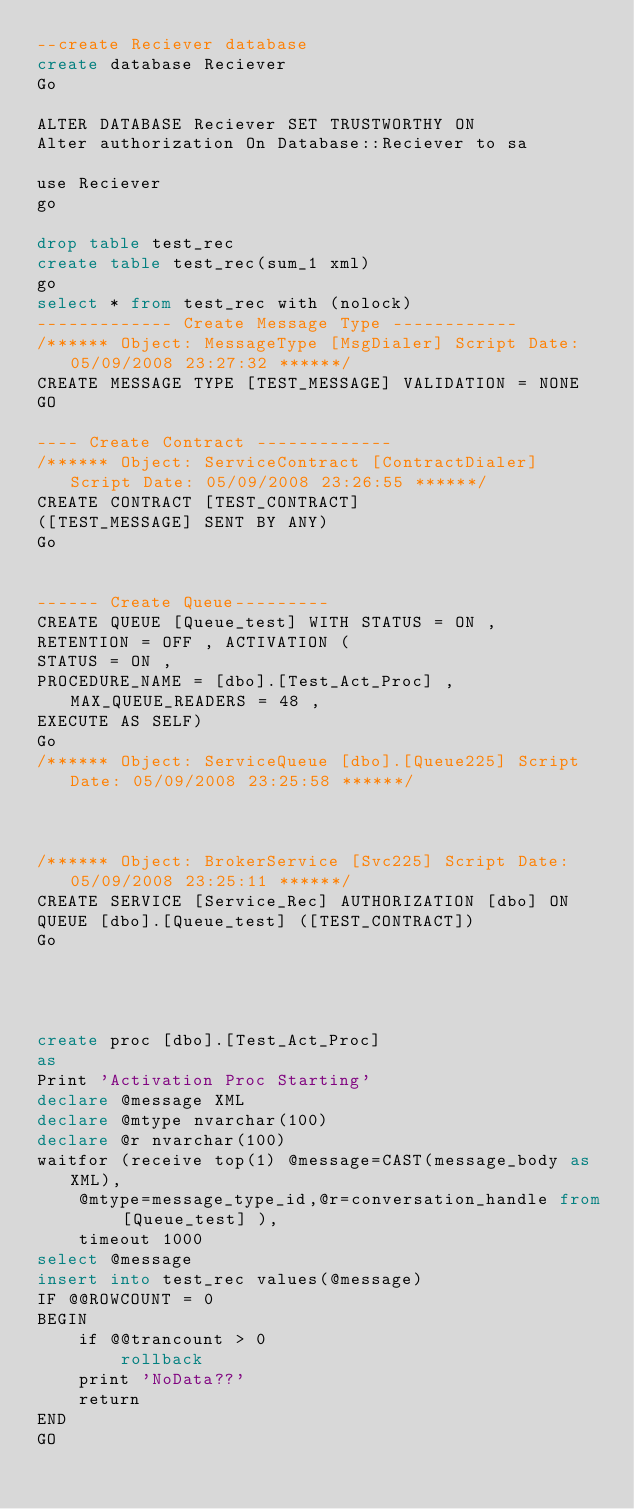Convert code to text. <code><loc_0><loc_0><loc_500><loc_500><_SQL_>--create Reciever database 
create database Reciever 
Go

ALTER DATABASE Reciever SET TRUSTWORTHY ON
Alter authorization On Database::Reciever to sa

use Reciever
go

drop table test_rec
create table test_rec(sum_1 xml)
go
select * from test_rec with (nolock)
------------- Create Message Type ------------
/****** Object: MessageType [MsgDialer] Script Date: 05/09/2008 23:27:32 ******/
CREATE MESSAGE TYPE [TEST_MESSAGE] VALIDATION = NONE
GO

---- Create Contract -------------
/****** Object: ServiceContract [ContractDialer] Script Date: 05/09/2008 23:26:55 ******/
CREATE CONTRACT [TEST_CONTRACT] 
([TEST_MESSAGE] SENT BY ANY)
Go


------ Create Queue---------
CREATE QUEUE [Queue_test] WITH STATUS = ON , 
RETENTION = OFF , ACTIVATION ( 
STATUS = ON , 
PROCEDURE_NAME = [dbo].[Test_Act_Proc] , MAX_QUEUE_READERS = 48 , 
EXECUTE AS SELF) 
Go
/****** Object: ServiceQueue [dbo].[Queue225] Script Date: 05/09/2008 23:25:58 ******/



/****** Object: BrokerService [Svc225] Script Date: 05/09/2008 23:25:11 ******/
CREATE SERVICE [Service_Rec] AUTHORIZATION [dbo] ON 
QUEUE [dbo].[Queue_test] ([TEST_CONTRACT])
Go




create proc [dbo].[Test_Act_Proc]
as 
Print 'Activation Proc Starting'
declare @message XML
declare @mtype nvarchar(100)
declare @r nvarchar(100)
waitfor (receive top(1) @message=CAST(message_body as XML),
	@mtype=message_type_id,@r=conversation_handle from [Queue_test] ), 
	timeout 1000
select @message
insert into test_rec values(@message)
IF @@ROWCOUNT = 0 
BEGIN
	if @@trancount > 0
		rollback
	print 'NoData??'
	return
END
GO





 </code> 